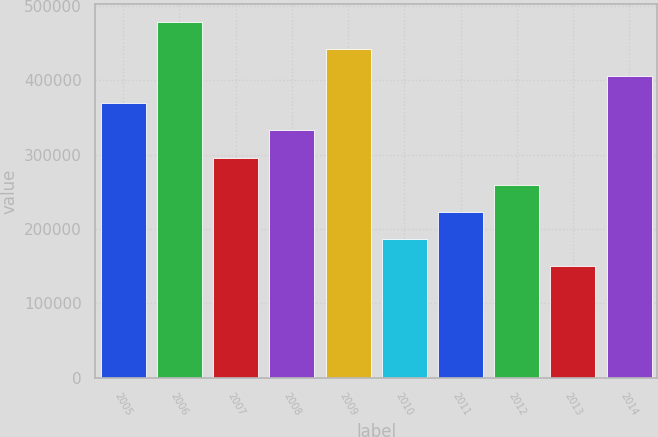<chart> <loc_0><loc_0><loc_500><loc_500><bar_chart><fcel>2005<fcel>2006<fcel>2007<fcel>2008<fcel>2009<fcel>2010<fcel>2011<fcel>2012<fcel>2013<fcel>2014<nl><fcel>369112<fcel>478667<fcel>296074<fcel>332593<fcel>442149<fcel>186519<fcel>223037<fcel>259556<fcel>150000<fcel>405630<nl></chart> 